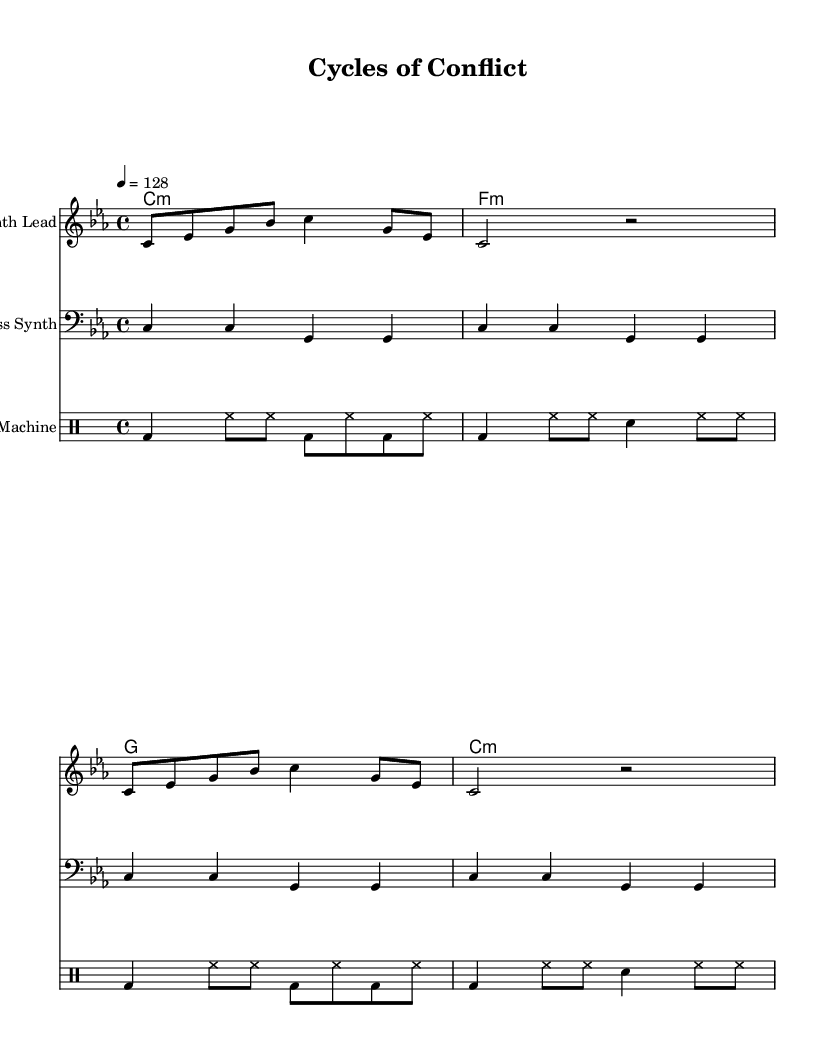What is the key signature of this music? The key signature is C minor, indicated by the presence of three flats (B♭, E♭, A♭).
Answer: C minor What is the time signature of the piece? The time signature is 4/4, which means there are four beats per measure and the quarter note gets one beat.
Answer: 4/4 What is the tempo marking of the composition? The tempo marking is set at 128 beats per minute, as indicated by the tempo instruction.
Answer: 128 How many measures are in the Synth Lead section? The Synth Lead section has eight measures, as the music is organized in groups of measures without repeats or additional sections indicated.
Answer: 8 What type of instrument is indicated for the Bass Synth? The instrument for the Bass Synth is specified as "Bass Synth" in the staff designation, indicating a synth sound typically used for bass lines.
Answer: Bass Synth What rhythmic pattern is primarily used in the drum machine part? The primary rhythmic pattern features a combination of bass drum and hi-hat, highlighting a driving techno beat that alternates between open and closed hi-hat.
Answer: Bass drum and hi-hat What do the chord symbols indicate in terms of harmony? The chord symbols indicate a progression of C minor, F minor, G major, and C minor, outlining the harmonic structure while reflecting a consistent moody and tension-building atmosphere typical in techno music.
Answer: C minor, F minor, G major, C minor 